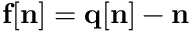Convert formula to latex. <formula><loc_0><loc_0><loc_500><loc_500>{ f } [ { n } ] = { q } [ { n } ] - { n }</formula> 